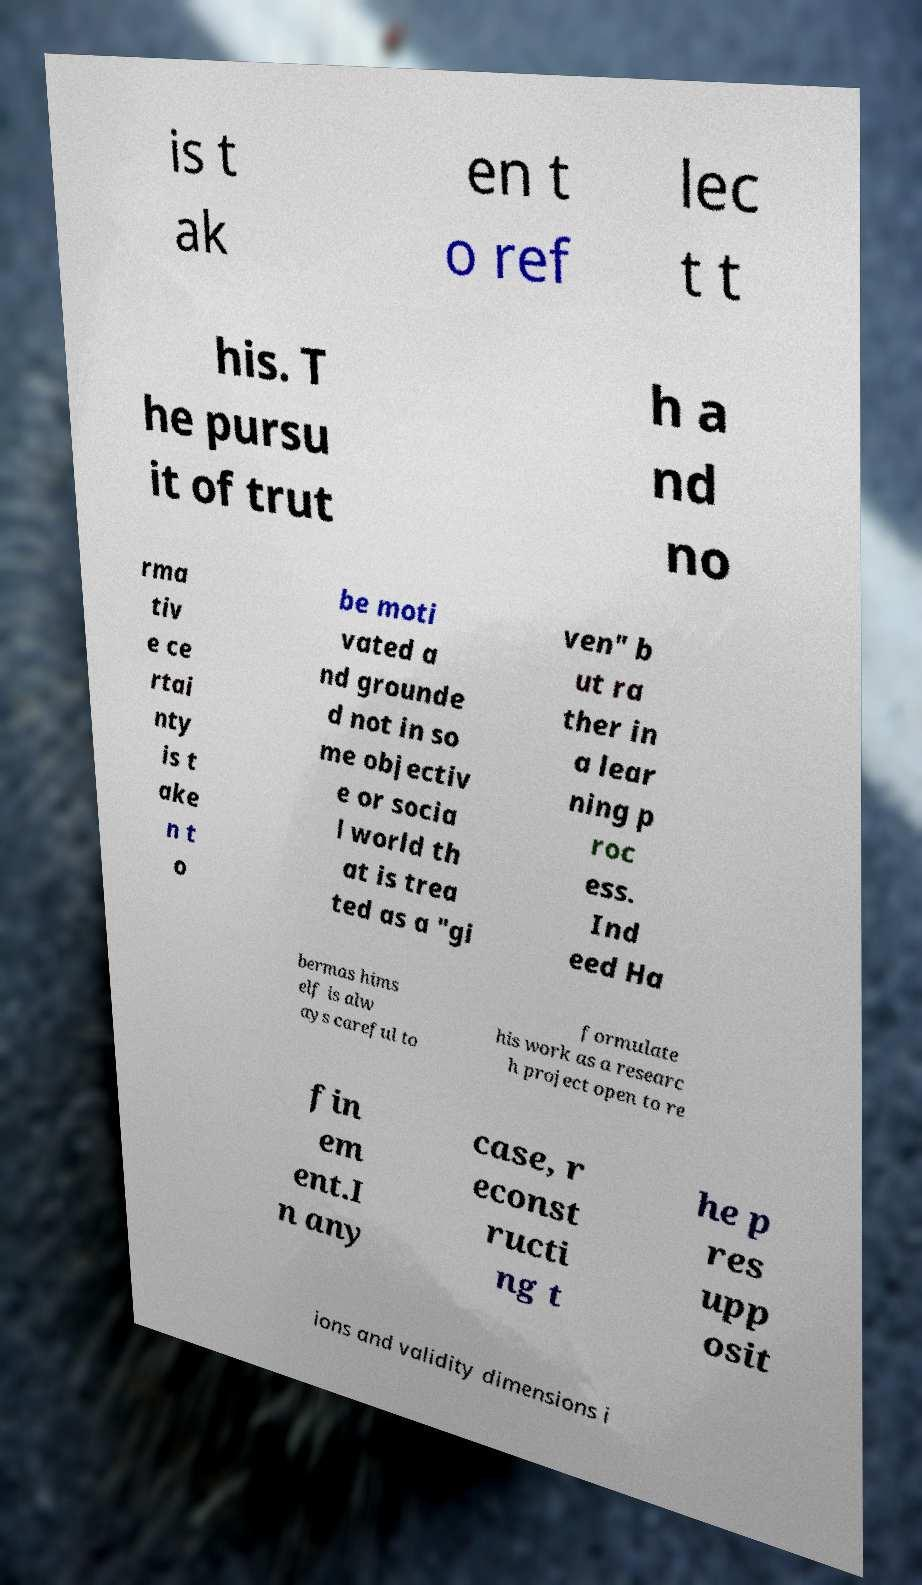There's text embedded in this image that I need extracted. Can you transcribe it verbatim? is t ak en t o ref lec t t his. T he pursu it of trut h a nd no rma tiv e ce rtai nty is t ake n t o be moti vated a nd grounde d not in so me objectiv e or socia l world th at is trea ted as a "gi ven" b ut ra ther in a lear ning p roc ess. Ind eed Ha bermas hims elf is alw ays careful to formulate his work as a researc h project open to re fin em ent.I n any case, r econst ructi ng t he p res upp osit ions and validity dimensions i 